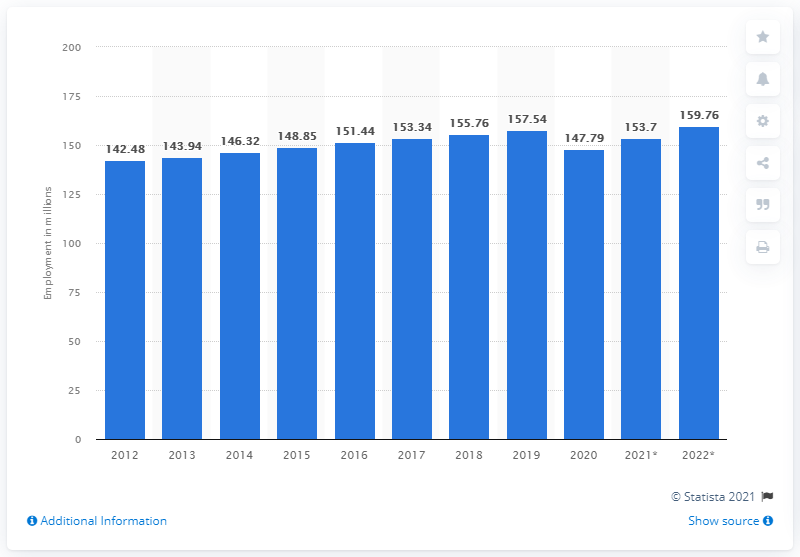Mention a couple of crucial points in this snapshot. In 2019, there were approximately 157.54 million people employed in the United States. 